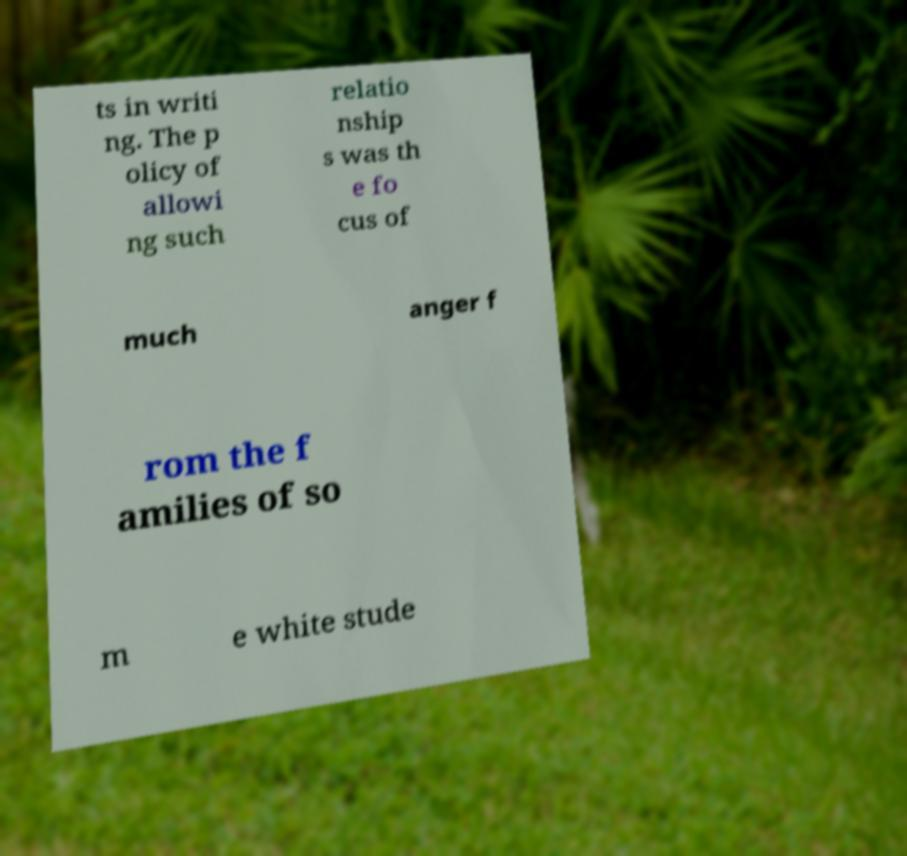Could you extract and type out the text from this image? ts in writi ng. The p olicy of allowi ng such relatio nship s was th e fo cus of much anger f rom the f amilies of so m e white stude 